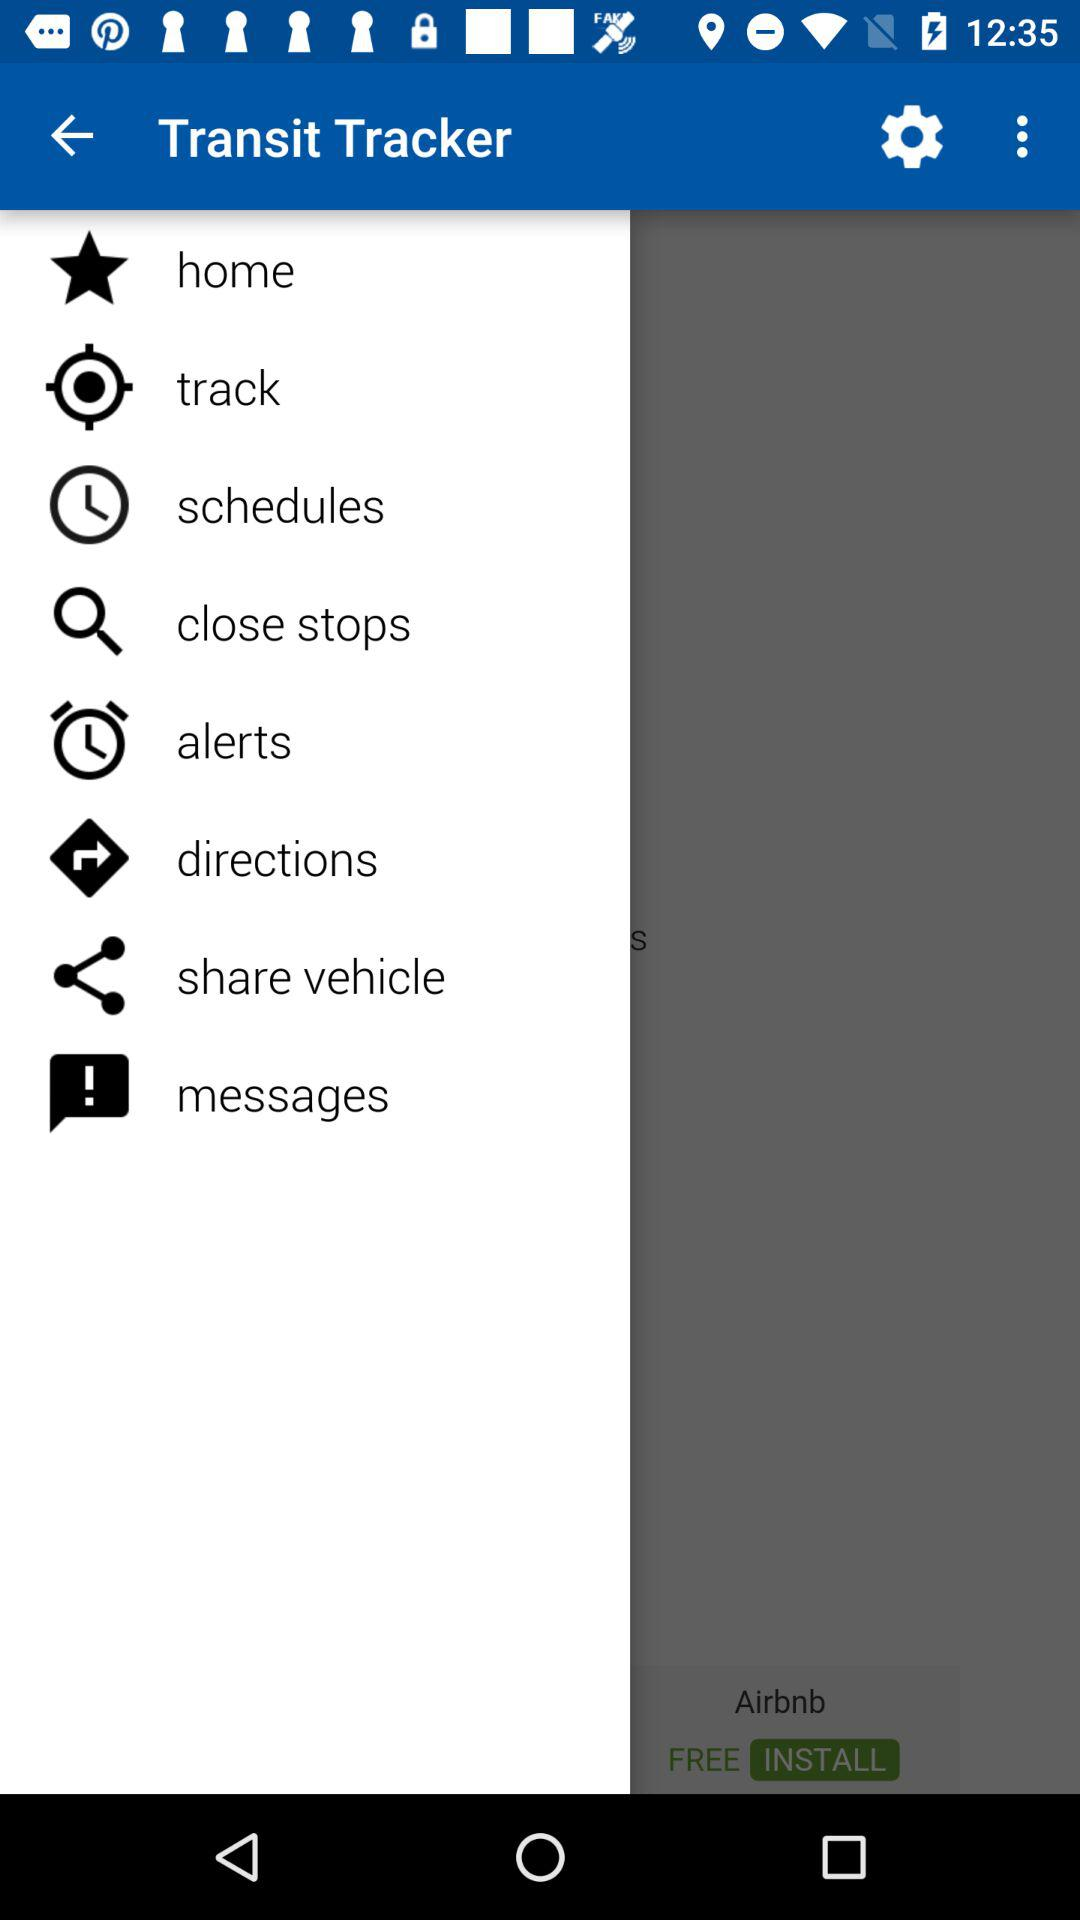What is the name of the application? The name of the application is "Transit Tracker". 